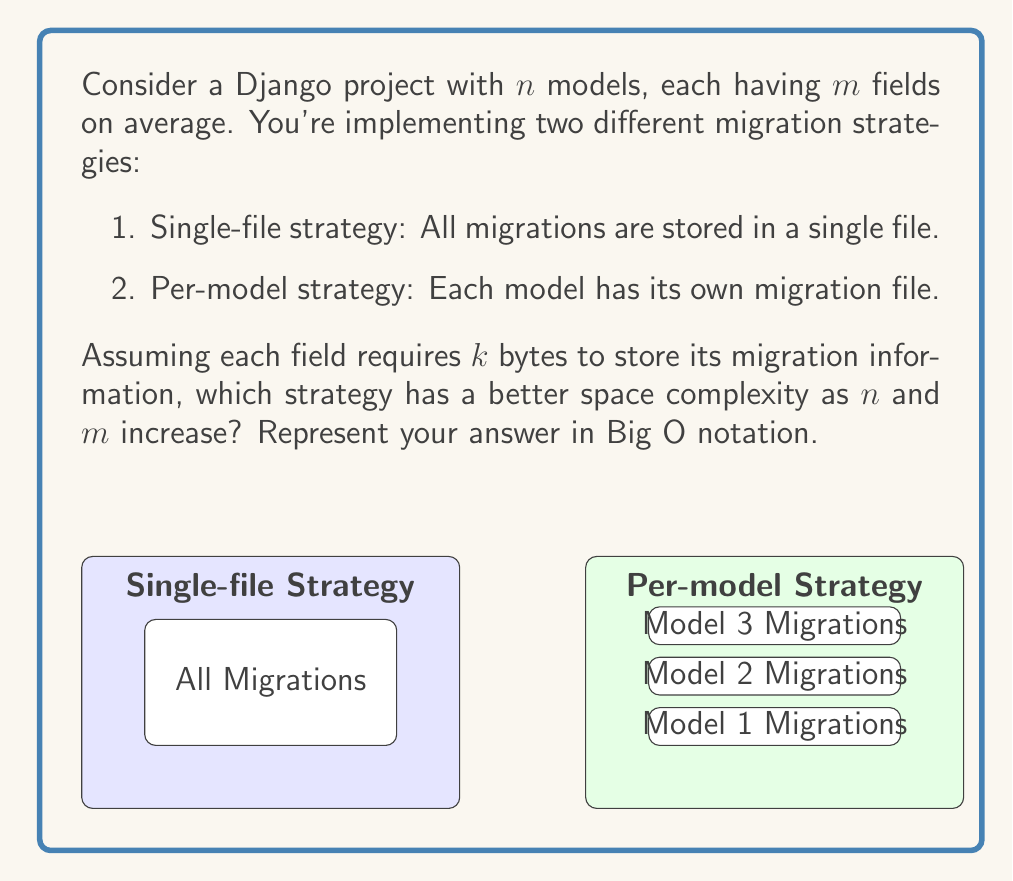Could you help me with this problem? Let's analyze the space complexity of both strategies:

1. Single-file strategy:
   - Total number of fields across all models: $n * m$
   - Space required for all fields: $n * m * k$ bytes
   - Space complexity: $O(n * m)$

2. Per-model strategy:
   - Number of migration files: $n$
   - Each file contains information for $m$ fields on average
   - Space required for each file: $m * k$ bytes
   - Total space required: $n * (m * k)$ bytes
   - Space complexity: $O(n * m)$

Both strategies have the same asymptotic space complexity of $O(n * m)$. However, the per-model strategy might have a slightly larger constant factor due to the overhead of maintaining multiple files.

In practice, the per-model strategy is often preferred in Django because:
1. It allows for better version control and conflict resolution when multiple developers work on different models.
2. It provides better organization and easier maintenance of migrations.
3. It allows for more granular control over migrations, especially when reverting changes.

The space complexity remains the same for both strategies because they ultimately store the same information, just in different organizational structures.
Answer: $O(n * m)$ for both strategies 